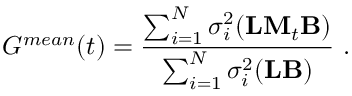Convert formula to latex. <formula><loc_0><loc_0><loc_500><loc_500>G ^ { m e a n } ( t ) = \frac { \sum _ { i = 1 } ^ { N } \sigma _ { i } ^ { 2 } ( { L } { M } _ { t } { B } ) } { \sum _ { i = 1 } ^ { N } \sigma _ { i } ^ { 2 } ( { L } { B } ) } .</formula> 